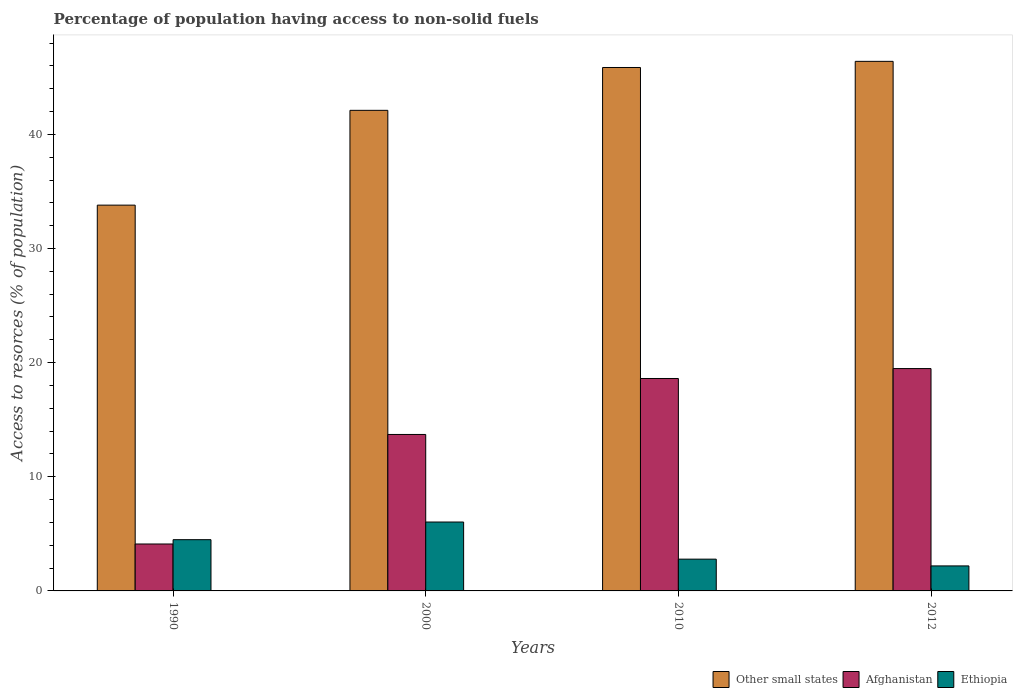How many groups of bars are there?
Your response must be concise. 4. Are the number of bars on each tick of the X-axis equal?
Ensure brevity in your answer.  Yes. How many bars are there on the 2nd tick from the right?
Provide a short and direct response. 3. What is the label of the 1st group of bars from the left?
Keep it short and to the point. 1990. In how many cases, is the number of bars for a given year not equal to the number of legend labels?
Keep it short and to the point. 0. What is the percentage of population having access to non-solid fuels in Other small states in 2000?
Keep it short and to the point. 42.11. Across all years, what is the maximum percentage of population having access to non-solid fuels in Other small states?
Keep it short and to the point. 46.4. Across all years, what is the minimum percentage of population having access to non-solid fuels in Other small states?
Provide a short and direct response. 33.8. What is the total percentage of population having access to non-solid fuels in Ethiopia in the graph?
Your response must be concise. 15.5. What is the difference between the percentage of population having access to non-solid fuels in Ethiopia in 1990 and that in 2000?
Give a very brief answer. -1.55. What is the difference between the percentage of population having access to non-solid fuels in Other small states in 2000 and the percentage of population having access to non-solid fuels in Ethiopia in 2012?
Make the answer very short. 39.91. What is the average percentage of population having access to non-solid fuels in Other small states per year?
Ensure brevity in your answer.  42.04. In the year 1990, what is the difference between the percentage of population having access to non-solid fuels in Other small states and percentage of population having access to non-solid fuels in Ethiopia?
Keep it short and to the point. 29.31. In how many years, is the percentage of population having access to non-solid fuels in Afghanistan greater than 44 %?
Offer a terse response. 0. What is the ratio of the percentage of population having access to non-solid fuels in Other small states in 1990 to that in 2012?
Your answer should be very brief. 0.73. Is the percentage of population having access to non-solid fuels in Other small states in 2000 less than that in 2012?
Give a very brief answer. Yes. What is the difference between the highest and the second highest percentage of population having access to non-solid fuels in Other small states?
Your answer should be compact. 0.54. What is the difference between the highest and the lowest percentage of population having access to non-solid fuels in Afghanistan?
Provide a short and direct response. 15.37. In how many years, is the percentage of population having access to non-solid fuels in Ethiopia greater than the average percentage of population having access to non-solid fuels in Ethiopia taken over all years?
Make the answer very short. 2. Is the sum of the percentage of population having access to non-solid fuels in Other small states in 2000 and 2012 greater than the maximum percentage of population having access to non-solid fuels in Ethiopia across all years?
Make the answer very short. Yes. What does the 3rd bar from the left in 2000 represents?
Provide a succinct answer. Ethiopia. What does the 1st bar from the right in 2010 represents?
Your answer should be compact. Ethiopia. Is it the case that in every year, the sum of the percentage of population having access to non-solid fuels in Afghanistan and percentage of population having access to non-solid fuels in Ethiopia is greater than the percentage of population having access to non-solid fuels in Other small states?
Give a very brief answer. No. How many bars are there?
Offer a terse response. 12. Are all the bars in the graph horizontal?
Make the answer very short. No. What is the difference between two consecutive major ticks on the Y-axis?
Offer a very short reply. 10. Are the values on the major ticks of Y-axis written in scientific E-notation?
Your response must be concise. No. Where does the legend appear in the graph?
Provide a succinct answer. Bottom right. What is the title of the graph?
Keep it short and to the point. Percentage of population having access to non-solid fuels. What is the label or title of the Y-axis?
Keep it short and to the point. Access to resorces (% of population). What is the Access to resorces (% of population) in Other small states in 1990?
Make the answer very short. 33.8. What is the Access to resorces (% of population) of Afghanistan in 1990?
Offer a terse response. 4.11. What is the Access to resorces (% of population) in Ethiopia in 1990?
Make the answer very short. 4.49. What is the Access to resorces (% of population) of Other small states in 2000?
Provide a succinct answer. 42.11. What is the Access to resorces (% of population) of Afghanistan in 2000?
Offer a very short reply. 13.71. What is the Access to resorces (% of population) of Ethiopia in 2000?
Give a very brief answer. 6.04. What is the Access to resorces (% of population) of Other small states in 2010?
Give a very brief answer. 45.86. What is the Access to resorces (% of population) of Afghanistan in 2010?
Offer a very short reply. 18.61. What is the Access to resorces (% of population) of Ethiopia in 2010?
Your response must be concise. 2.78. What is the Access to resorces (% of population) of Other small states in 2012?
Your answer should be very brief. 46.4. What is the Access to resorces (% of population) of Afghanistan in 2012?
Provide a short and direct response. 19.48. What is the Access to resorces (% of population) in Ethiopia in 2012?
Give a very brief answer. 2.19. Across all years, what is the maximum Access to resorces (% of population) in Other small states?
Provide a succinct answer. 46.4. Across all years, what is the maximum Access to resorces (% of population) of Afghanistan?
Offer a terse response. 19.48. Across all years, what is the maximum Access to resorces (% of population) of Ethiopia?
Your answer should be compact. 6.04. Across all years, what is the minimum Access to resorces (% of population) of Other small states?
Provide a short and direct response. 33.8. Across all years, what is the minimum Access to resorces (% of population) of Afghanistan?
Keep it short and to the point. 4.11. Across all years, what is the minimum Access to resorces (% of population) of Ethiopia?
Your answer should be compact. 2.19. What is the total Access to resorces (% of population) of Other small states in the graph?
Your response must be concise. 168.16. What is the total Access to resorces (% of population) of Afghanistan in the graph?
Keep it short and to the point. 55.91. What is the total Access to resorces (% of population) of Ethiopia in the graph?
Ensure brevity in your answer.  15.5. What is the difference between the Access to resorces (% of population) in Other small states in 1990 and that in 2000?
Offer a terse response. -8.31. What is the difference between the Access to resorces (% of population) of Afghanistan in 1990 and that in 2000?
Your answer should be very brief. -9.6. What is the difference between the Access to resorces (% of population) of Ethiopia in 1990 and that in 2000?
Keep it short and to the point. -1.55. What is the difference between the Access to resorces (% of population) of Other small states in 1990 and that in 2010?
Your answer should be very brief. -12.06. What is the difference between the Access to resorces (% of population) of Afghanistan in 1990 and that in 2010?
Your answer should be very brief. -14.5. What is the difference between the Access to resorces (% of population) in Ethiopia in 1990 and that in 2010?
Provide a succinct answer. 1.71. What is the difference between the Access to resorces (% of population) of Other small states in 1990 and that in 2012?
Your answer should be compact. -12.6. What is the difference between the Access to resorces (% of population) in Afghanistan in 1990 and that in 2012?
Provide a succinct answer. -15.37. What is the difference between the Access to resorces (% of population) of Ethiopia in 1990 and that in 2012?
Your answer should be very brief. 2.3. What is the difference between the Access to resorces (% of population) of Other small states in 2000 and that in 2010?
Ensure brevity in your answer.  -3.75. What is the difference between the Access to resorces (% of population) of Afghanistan in 2000 and that in 2010?
Keep it short and to the point. -4.9. What is the difference between the Access to resorces (% of population) of Ethiopia in 2000 and that in 2010?
Offer a very short reply. 3.25. What is the difference between the Access to resorces (% of population) in Other small states in 2000 and that in 2012?
Offer a terse response. -4.29. What is the difference between the Access to resorces (% of population) in Afghanistan in 2000 and that in 2012?
Ensure brevity in your answer.  -5.77. What is the difference between the Access to resorces (% of population) of Ethiopia in 2000 and that in 2012?
Provide a short and direct response. 3.84. What is the difference between the Access to resorces (% of population) of Other small states in 2010 and that in 2012?
Give a very brief answer. -0.54. What is the difference between the Access to resorces (% of population) of Afghanistan in 2010 and that in 2012?
Your answer should be very brief. -0.87. What is the difference between the Access to resorces (% of population) of Ethiopia in 2010 and that in 2012?
Ensure brevity in your answer.  0.59. What is the difference between the Access to resorces (% of population) in Other small states in 1990 and the Access to resorces (% of population) in Afghanistan in 2000?
Make the answer very short. 20.09. What is the difference between the Access to resorces (% of population) in Other small states in 1990 and the Access to resorces (% of population) in Ethiopia in 2000?
Provide a short and direct response. 27.76. What is the difference between the Access to resorces (% of population) of Afghanistan in 1990 and the Access to resorces (% of population) of Ethiopia in 2000?
Your response must be concise. -1.92. What is the difference between the Access to resorces (% of population) of Other small states in 1990 and the Access to resorces (% of population) of Afghanistan in 2010?
Keep it short and to the point. 15.19. What is the difference between the Access to resorces (% of population) in Other small states in 1990 and the Access to resorces (% of population) in Ethiopia in 2010?
Provide a succinct answer. 31.02. What is the difference between the Access to resorces (% of population) in Afghanistan in 1990 and the Access to resorces (% of population) in Ethiopia in 2010?
Give a very brief answer. 1.33. What is the difference between the Access to resorces (% of population) of Other small states in 1990 and the Access to resorces (% of population) of Afghanistan in 2012?
Provide a short and direct response. 14.32. What is the difference between the Access to resorces (% of population) in Other small states in 1990 and the Access to resorces (% of population) in Ethiopia in 2012?
Offer a terse response. 31.61. What is the difference between the Access to resorces (% of population) of Afghanistan in 1990 and the Access to resorces (% of population) of Ethiopia in 2012?
Provide a short and direct response. 1.92. What is the difference between the Access to resorces (% of population) of Other small states in 2000 and the Access to resorces (% of population) of Afghanistan in 2010?
Make the answer very short. 23.49. What is the difference between the Access to resorces (% of population) in Other small states in 2000 and the Access to resorces (% of population) in Ethiopia in 2010?
Keep it short and to the point. 39.32. What is the difference between the Access to resorces (% of population) in Afghanistan in 2000 and the Access to resorces (% of population) in Ethiopia in 2010?
Your answer should be compact. 10.92. What is the difference between the Access to resorces (% of population) of Other small states in 2000 and the Access to resorces (% of population) of Afghanistan in 2012?
Ensure brevity in your answer.  22.62. What is the difference between the Access to resorces (% of population) in Other small states in 2000 and the Access to resorces (% of population) in Ethiopia in 2012?
Provide a short and direct response. 39.91. What is the difference between the Access to resorces (% of population) in Afghanistan in 2000 and the Access to resorces (% of population) in Ethiopia in 2012?
Offer a terse response. 11.52. What is the difference between the Access to resorces (% of population) in Other small states in 2010 and the Access to resorces (% of population) in Afghanistan in 2012?
Provide a short and direct response. 26.38. What is the difference between the Access to resorces (% of population) of Other small states in 2010 and the Access to resorces (% of population) of Ethiopia in 2012?
Your answer should be compact. 43.67. What is the difference between the Access to resorces (% of population) of Afghanistan in 2010 and the Access to resorces (% of population) of Ethiopia in 2012?
Provide a succinct answer. 16.42. What is the average Access to resorces (% of population) of Other small states per year?
Provide a short and direct response. 42.04. What is the average Access to resorces (% of population) of Afghanistan per year?
Your answer should be very brief. 13.98. What is the average Access to resorces (% of population) of Ethiopia per year?
Ensure brevity in your answer.  3.88. In the year 1990, what is the difference between the Access to resorces (% of population) in Other small states and Access to resorces (% of population) in Afghanistan?
Provide a short and direct response. 29.69. In the year 1990, what is the difference between the Access to resorces (% of population) of Other small states and Access to resorces (% of population) of Ethiopia?
Offer a terse response. 29.31. In the year 1990, what is the difference between the Access to resorces (% of population) of Afghanistan and Access to resorces (% of population) of Ethiopia?
Offer a very short reply. -0.38. In the year 2000, what is the difference between the Access to resorces (% of population) of Other small states and Access to resorces (% of population) of Afghanistan?
Your response must be concise. 28.4. In the year 2000, what is the difference between the Access to resorces (% of population) in Other small states and Access to resorces (% of population) in Ethiopia?
Provide a short and direct response. 36.07. In the year 2000, what is the difference between the Access to resorces (% of population) in Afghanistan and Access to resorces (% of population) in Ethiopia?
Your answer should be compact. 7.67. In the year 2010, what is the difference between the Access to resorces (% of population) of Other small states and Access to resorces (% of population) of Afghanistan?
Make the answer very short. 27.25. In the year 2010, what is the difference between the Access to resorces (% of population) in Other small states and Access to resorces (% of population) in Ethiopia?
Provide a succinct answer. 43.08. In the year 2010, what is the difference between the Access to resorces (% of population) of Afghanistan and Access to resorces (% of population) of Ethiopia?
Offer a very short reply. 15.83. In the year 2012, what is the difference between the Access to resorces (% of population) in Other small states and Access to resorces (% of population) in Afghanistan?
Make the answer very short. 26.92. In the year 2012, what is the difference between the Access to resorces (% of population) of Other small states and Access to resorces (% of population) of Ethiopia?
Ensure brevity in your answer.  44.21. In the year 2012, what is the difference between the Access to resorces (% of population) in Afghanistan and Access to resorces (% of population) in Ethiopia?
Offer a terse response. 17.29. What is the ratio of the Access to resorces (% of population) in Other small states in 1990 to that in 2000?
Offer a terse response. 0.8. What is the ratio of the Access to resorces (% of population) of Afghanistan in 1990 to that in 2000?
Make the answer very short. 0.3. What is the ratio of the Access to resorces (% of population) in Ethiopia in 1990 to that in 2000?
Provide a succinct answer. 0.74. What is the ratio of the Access to resorces (% of population) of Other small states in 1990 to that in 2010?
Offer a terse response. 0.74. What is the ratio of the Access to resorces (% of population) of Afghanistan in 1990 to that in 2010?
Make the answer very short. 0.22. What is the ratio of the Access to resorces (% of population) of Ethiopia in 1990 to that in 2010?
Make the answer very short. 1.61. What is the ratio of the Access to resorces (% of population) of Other small states in 1990 to that in 2012?
Your response must be concise. 0.73. What is the ratio of the Access to resorces (% of population) in Afghanistan in 1990 to that in 2012?
Make the answer very short. 0.21. What is the ratio of the Access to resorces (% of population) of Ethiopia in 1990 to that in 2012?
Provide a short and direct response. 2.05. What is the ratio of the Access to resorces (% of population) of Other small states in 2000 to that in 2010?
Offer a very short reply. 0.92. What is the ratio of the Access to resorces (% of population) of Afghanistan in 2000 to that in 2010?
Keep it short and to the point. 0.74. What is the ratio of the Access to resorces (% of population) in Ethiopia in 2000 to that in 2010?
Your answer should be very brief. 2.17. What is the ratio of the Access to resorces (% of population) of Other small states in 2000 to that in 2012?
Give a very brief answer. 0.91. What is the ratio of the Access to resorces (% of population) of Afghanistan in 2000 to that in 2012?
Ensure brevity in your answer.  0.7. What is the ratio of the Access to resorces (% of population) of Ethiopia in 2000 to that in 2012?
Offer a very short reply. 2.75. What is the ratio of the Access to resorces (% of population) of Other small states in 2010 to that in 2012?
Offer a terse response. 0.99. What is the ratio of the Access to resorces (% of population) in Afghanistan in 2010 to that in 2012?
Your answer should be very brief. 0.96. What is the ratio of the Access to resorces (% of population) of Ethiopia in 2010 to that in 2012?
Your response must be concise. 1.27. What is the difference between the highest and the second highest Access to resorces (% of population) in Other small states?
Give a very brief answer. 0.54. What is the difference between the highest and the second highest Access to resorces (% of population) of Afghanistan?
Provide a short and direct response. 0.87. What is the difference between the highest and the second highest Access to resorces (% of population) of Ethiopia?
Your answer should be compact. 1.55. What is the difference between the highest and the lowest Access to resorces (% of population) of Other small states?
Make the answer very short. 12.6. What is the difference between the highest and the lowest Access to resorces (% of population) of Afghanistan?
Keep it short and to the point. 15.37. What is the difference between the highest and the lowest Access to resorces (% of population) of Ethiopia?
Give a very brief answer. 3.84. 